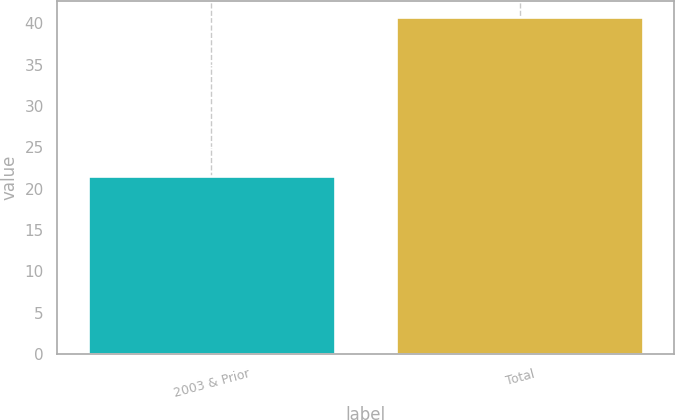Convert chart. <chart><loc_0><loc_0><loc_500><loc_500><bar_chart><fcel>2003 & Prior<fcel>Total<nl><fcel>21.5<fcel>40.7<nl></chart> 